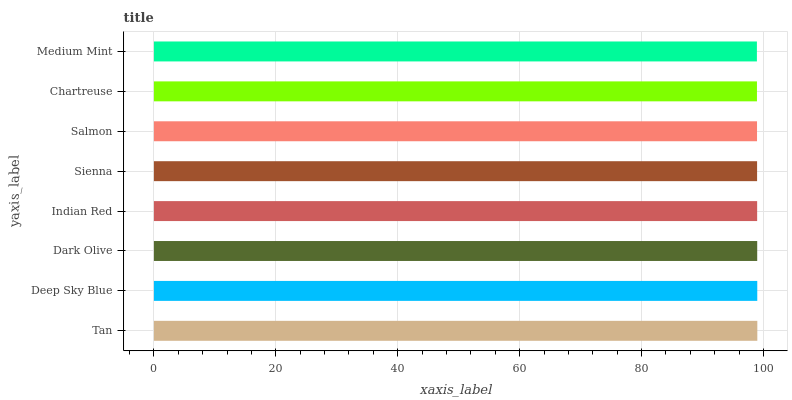Is Medium Mint the minimum?
Answer yes or no. Yes. Is Tan the maximum?
Answer yes or no. Yes. Is Deep Sky Blue the minimum?
Answer yes or no. No. Is Deep Sky Blue the maximum?
Answer yes or no. No. Is Tan greater than Deep Sky Blue?
Answer yes or no. Yes. Is Deep Sky Blue less than Tan?
Answer yes or no. Yes. Is Deep Sky Blue greater than Tan?
Answer yes or no. No. Is Tan less than Deep Sky Blue?
Answer yes or no. No. Is Indian Red the high median?
Answer yes or no. Yes. Is Sienna the low median?
Answer yes or no. Yes. Is Deep Sky Blue the high median?
Answer yes or no. No. Is Salmon the low median?
Answer yes or no. No. 